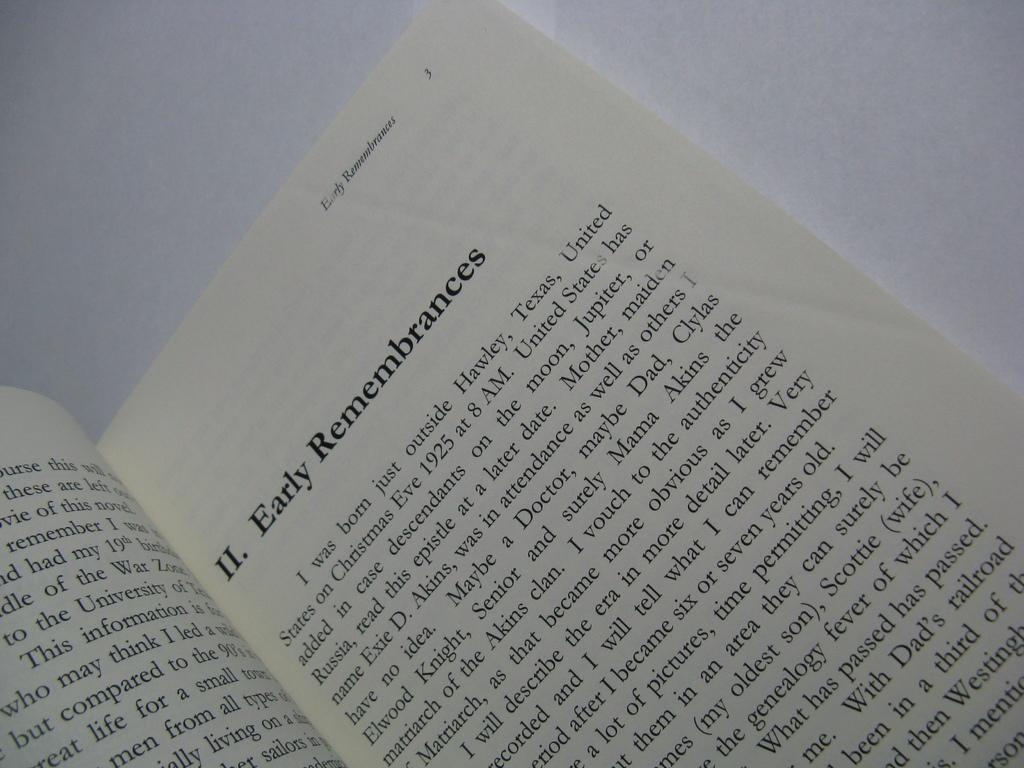<image>
Give a short and clear explanation of the subsequent image. A book is open to II. Early Remembrences. 